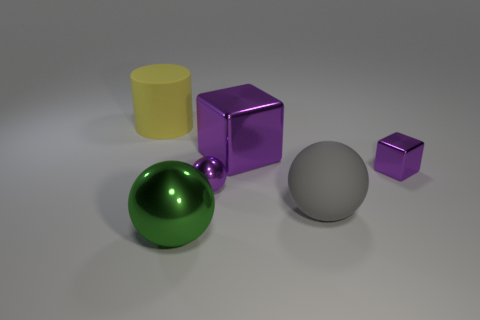Imagine these objects are part of a game. How would you describe the game's objective using these shapes? Let's envision this as a strategic sorting game where players have to group objects by either shape or color within a time limit, under the pretense that they are helping an artist organize their studio. This game tests the players' quick recognition of attributes and decision-making skills under pressure. 